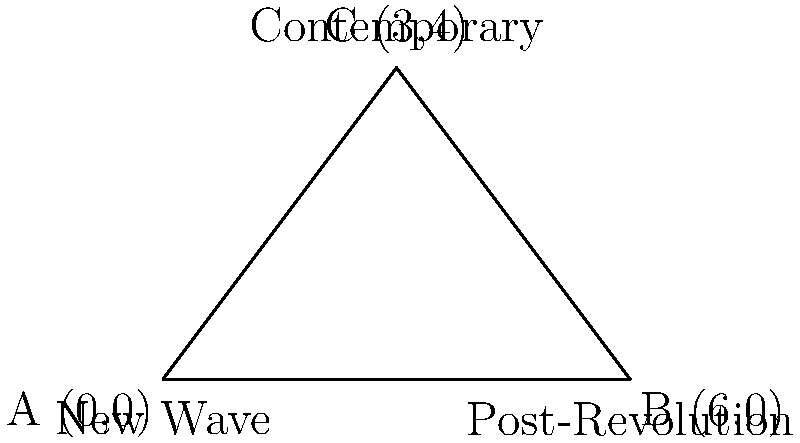In the graph above, three points represent different eras of Iranian cinema: A (0,0) for the New Wave, B (6,0) for Post-Revolution, and C (3,4) for Contemporary. Calculate the area of the triangle formed by these points, which symbolizes the evolution of Iranian cinema through these movements. How does this area reflect the impact of the Jalilvand brothers' work within the contemporary Iranian film landscape? To calculate the area of the triangle, we'll use the formula:

Area = $\frac{1}{2}|x_1(y_2 - y_3) + x_2(y_3 - y_1) + x_3(y_1 - y_2)|$

Where $(x_1, y_1)$, $(x_2, y_2)$, and $(x_3, y_3)$ are the coordinates of the three points.

Step 1: Identify the coordinates
A (0,0), B (6,0), C (3,4)

Step 2: Apply the formula
Area = $\frac{1}{2}|0(0 - 4) + 6(4 - 0) + 3(0 - 0)|$
     = $\frac{1}{2}|0 + 24 + 0|$
     = $\frac{1}{2}(24)$
     = 12 square units

The area of 12 square units represents the expansive influence of these three major movements in Iranian cinema. The Jalilvand brothers, being contemporary filmmakers, are positioned at point C, which has the highest y-coordinate. This reflects their significant contribution to modern Iranian cinema, building upon the foundation laid by the New Wave and Post-Revolution eras. Their work, characterized by social realism and psychological depth, expands the triangle's area upward, symbolizing the growth and evolution of Iranian cinema in the contemporary period.
Answer: 12 square units 